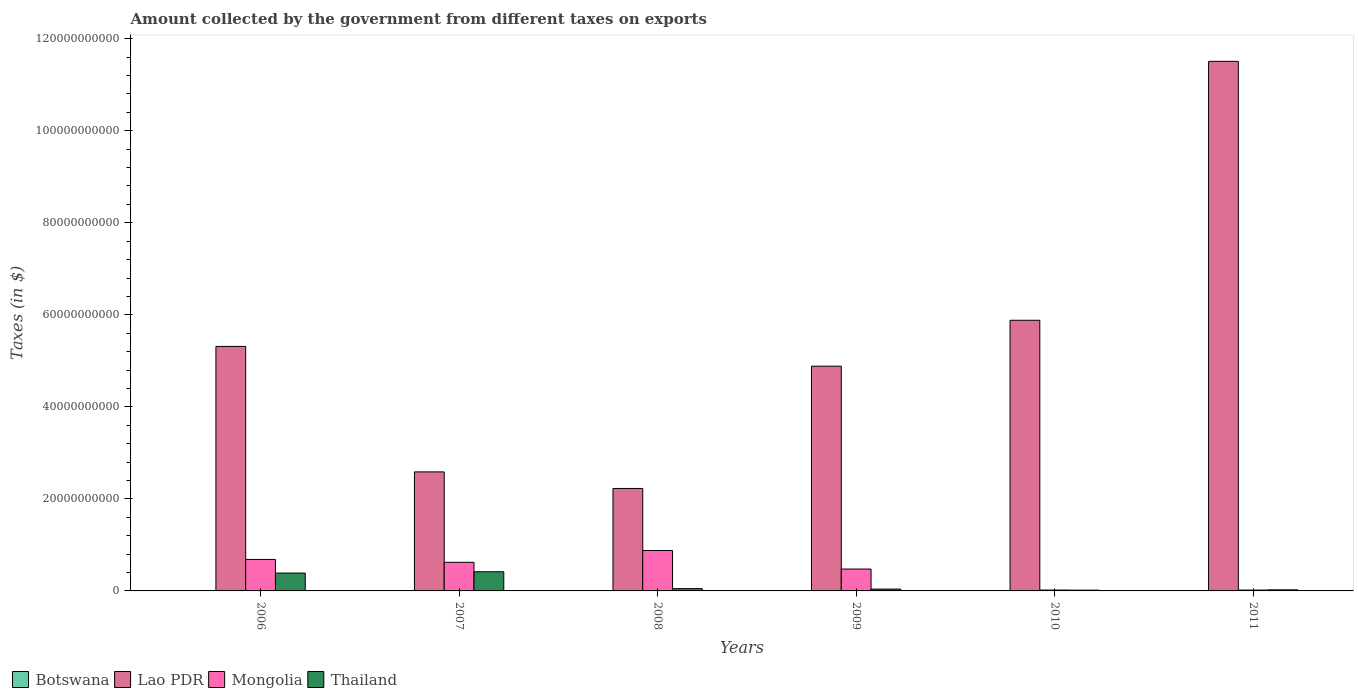How many different coloured bars are there?
Give a very brief answer. 4. Are the number of bars on each tick of the X-axis equal?
Your response must be concise. Yes. What is the label of the 4th group of bars from the left?
Provide a succinct answer. 2009. What is the amount collected by the government from taxes on exports in Lao PDR in 2011?
Offer a very short reply. 1.15e+11. Across all years, what is the maximum amount collected by the government from taxes on exports in Botswana?
Your answer should be compact. 1.69e+06. What is the total amount collected by the government from taxes on exports in Mongolia in the graph?
Offer a terse response. 2.70e+1. What is the difference between the amount collected by the government from taxes on exports in Thailand in 2008 and that in 2011?
Provide a short and direct response. 2.61e+08. What is the difference between the amount collected by the government from taxes on exports in Botswana in 2008 and the amount collected by the government from taxes on exports in Lao PDR in 2010?
Provide a succinct answer. -5.88e+1. What is the average amount collected by the government from taxes on exports in Botswana per year?
Ensure brevity in your answer.  1.04e+06. In the year 2008, what is the difference between the amount collected by the government from taxes on exports in Thailand and amount collected by the government from taxes on exports in Lao PDR?
Make the answer very short. -2.18e+1. In how many years, is the amount collected by the government from taxes on exports in Lao PDR greater than 40000000000 $?
Keep it short and to the point. 4. What is the ratio of the amount collected by the government from taxes on exports in Mongolia in 2009 to that in 2011?
Offer a terse response. 25.63. What is the difference between the highest and the second highest amount collected by the government from taxes on exports in Lao PDR?
Make the answer very short. 5.63e+1. What is the difference between the highest and the lowest amount collected by the government from taxes on exports in Lao PDR?
Give a very brief answer. 9.28e+1. In how many years, is the amount collected by the government from taxes on exports in Thailand greater than the average amount collected by the government from taxes on exports in Thailand taken over all years?
Your answer should be compact. 2. Is the sum of the amount collected by the government from taxes on exports in Lao PDR in 2007 and 2008 greater than the maximum amount collected by the government from taxes on exports in Botswana across all years?
Your response must be concise. Yes. What does the 2nd bar from the left in 2011 represents?
Your answer should be compact. Lao PDR. What does the 2nd bar from the right in 2011 represents?
Your response must be concise. Mongolia. Is it the case that in every year, the sum of the amount collected by the government from taxes on exports in Mongolia and amount collected by the government from taxes on exports in Botswana is greater than the amount collected by the government from taxes on exports in Lao PDR?
Your answer should be compact. No. Are the values on the major ticks of Y-axis written in scientific E-notation?
Your response must be concise. No. Where does the legend appear in the graph?
Your response must be concise. Bottom left. How many legend labels are there?
Provide a succinct answer. 4. What is the title of the graph?
Your response must be concise. Amount collected by the government from different taxes on exports. What is the label or title of the Y-axis?
Provide a succinct answer. Taxes (in $). What is the Taxes (in $) in Lao PDR in 2006?
Offer a very short reply. 5.31e+1. What is the Taxes (in $) in Mongolia in 2006?
Make the answer very short. 6.84e+09. What is the Taxes (in $) in Thailand in 2006?
Keep it short and to the point. 3.88e+09. What is the Taxes (in $) of Lao PDR in 2007?
Keep it short and to the point. 2.59e+1. What is the Taxes (in $) in Mongolia in 2007?
Keep it short and to the point. 6.22e+09. What is the Taxes (in $) of Thailand in 2007?
Provide a succinct answer. 4.16e+09. What is the Taxes (in $) in Botswana in 2008?
Give a very brief answer. 1.65e+06. What is the Taxes (in $) of Lao PDR in 2008?
Provide a short and direct response. 2.23e+1. What is the Taxes (in $) in Mongolia in 2008?
Offer a terse response. 8.78e+09. What is the Taxes (in $) in Botswana in 2009?
Provide a short and direct response. 7.10e+05. What is the Taxes (in $) of Lao PDR in 2009?
Keep it short and to the point. 4.88e+1. What is the Taxes (in $) in Mongolia in 2009?
Your response must be concise. 4.75e+09. What is the Taxes (in $) in Thailand in 2009?
Your answer should be very brief. 4.00e+08. What is the Taxes (in $) of Botswana in 2010?
Ensure brevity in your answer.  1.69e+06. What is the Taxes (in $) of Lao PDR in 2010?
Your response must be concise. 5.88e+1. What is the Taxes (in $) in Mongolia in 2010?
Provide a short and direct response. 1.90e+08. What is the Taxes (in $) of Thailand in 2010?
Provide a succinct answer. 1.68e+08. What is the Taxes (in $) of Botswana in 2011?
Offer a terse response. 1.36e+06. What is the Taxes (in $) of Lao PDR in 2011?
Provide a short and direct response. 1.15e+11. What is the Taxes (in $) in Mongolia in 2011?
Provide a short and direct response. 1.85e+08. What is the Taxes (in $) in Thailand in 2011?
Your answer should be very brief. 2.39e+08. Across all years, what is the maximum Taxes (in $) of Botswana?
Your answer should be compact. 1.69e+06. Across all years, what is the maximum Taxes (in $) of Lao PDR?
Give a very brief answer. 1.15e+11. Across all years, what is the maximum Taxes (in $) of Mongolia?
Provide a short and direct response. 8.78e+09. Across all years, what is the maximum Taxes (in $) of Thailand?
Offer a terse response. 4.16e+09. Across all years, what is the minimum Taxes (in $) in Botswana?
Your response must be concise. 3.60e+05. Across all years, what is the minimum Taxes (in $) in Lao PDR?
Keep it short and to the point. 2.23e+1. Across all years, what is the minimum Taxes (in $) of Mongolia?
Offer a very short reply. 1.85e+08. Across all years, what is the minimum Taxes (in $) of Thailand?
Offer a terse response. 1.68e+08. What is the total Taxes (in $) of Botswana in the graph?
Offer a very short reply. 6.21e+06. What is the total Taxes (in $) in Lao PDR in the graph?
Keep it short and to the point. 3.24e+11. What is the total Taxes (in $) in Mongolia in the graph?
Your response must be concise. 2.70e+1. What is the total Taxes (in $) of Thailand in the graph?
Your response must be concise. 9.35e+09. What is the difference between the Taxes (in $) in Botswana in 2006 and that in 2007?
Provide a short and direct response. -8.00e+04. What is the difference between the Taxes (in $) of Lao PDR in 2006 and that in 2007?
Your response must be concise. 2.73e+1. What is the difference between the Taxes (in $) of Mongolia in 2006 and that in 2007?
Offer a terse response. 6.22e+08. What is the difference between the Taxes (in $) of Thailand in 2006 and that in 2007?
Give a very brief answer. -2.84e+08. What is the difference between the Taxes (in $) in Botswana in 2006 and that in 2008?
Your answer should be very brief. -1.29e+06. What is the difference between the Taxes (in $) in Lao PDR in 2006 and that in 2008?
Make the answer very short. 3.09e+1. What is the difference between the Taxes (in $) in Mongolia in 2006 and that in 2008?
Make the answer very short. -1.94e+09. What is the difference between the Taxes (in $) of Thailand in 2006 and that in 2008?
Keep it short and to the point. 3.38e+09. What is the difference between the Taxes (in $) of Botswana in 2006 and that in 2009?
Keep it short and to the point. -3.50e+05. What is the difference between the Taxes (in $) in Lao PDR in 2006 and that in 2009?
Ensure brevity in your answer.  4.29e+09. What is the difference between the Taxes (in $) of Mongolia in 2006 and that in 2009?
Offer a terse response. 2.09e+09. What is the difference between the Taxes (in $) in Thailand in 2006 and that in 2009?
Provide a short and direct response. 3.48e+09. What is the difference between the Taxes (in $) of Botswana in 2006 and that in 2010?
Your answer should be very brief. -1.33e+06. What is the difference between the Taxes (in $) in Lao PDR in 2006 and that in 2010?
Give a very brief answer. -5.68e+09. What is the difference between the Taxes (in $) in Mongolia in 2006 and that in 2010?
Ensure brevity in your answer.  6.65e+09. What is the difference between the Taxes (in $) of Thailand in 2006 and that in 2010?
Your answer should be compact. 3.71e+09. What is the difference between the Taxes (in $) of Lao PDR in 2006 and that in 2011?
Make the answer very short. -6.19e+1. What is the difference between the Taxes (in $) of Mongolia in 2006 and that in 2011?
Keep it short and to the point. 6.65e+09. What is the difference between the Taxes (in $) of Thailand in 2006 and that in 2011?
Your answer should be compact. 3.64e+09. What is the difference between the Taxes (in $) of Botswana in 2007 and that in 2008?
Provide a succinct answer. -1.21e+06. What is the difference between the Taxes (in $) in Lao PDR in 2007 and that in 2008?
Provide a short and direct response. 3.60e+09. What is the difference between the Taxes (in $) in Mongolia in 2007 and that in 2008?
Your response must be concise. -2.56e+09. What is the difference between the Taxes (in $) of Thailand in 2007 and that in 2008?
Your answer should be compact. 3.66e+09. What is the difference between the Taxes (in $) in Lao PDR in 2007 and that in 2009?
Offer a very short reply. -2.30e+1. What is the difference between the Taxes (in $) in Mongolia in 2007 and that in 2009?
Give a very brief answer. 1.46e+09. What is the difference between the Taxes (in $) in Thailand in 2007 and that in 2009?
Offer a terse response. 3.76e+09. What is the difference between the Taxes (in $) in Botswana in 2007 and that in 2010?
Offer a very short reply. -1.25e+06. What is the difference between the Taxes (in $) of Lao PDR in 2007 and that in 2010?
Ensure brevity in your answer.  -3.30e+1. What is the difference between the Taxes (in $) in Mongolia in 2007 and that in 2010?
Your answer should be very brief. 6.03e+09. What is the difference between the Taxes (in $) in Thailand in 2007 and that in 2010?
Make the answer very short. 4.00e+09. What is the difference between the Taxes (in $) in Botswana in 2007 and that in 2011?
Keep it short and to the point. -9.20e+05. What is the difference between the Taxes (in $) of Lao PDR in 2007 and that in 2011?
Make the answer very short. -8.92e+1. What is the difference between the Taxes (in $) of Mongolia in 2007 and that in 2011?
Give a very brief answer. 6.03e+09. What is the difference between the Taxes (in $) of Thailand in 2007 and that in 2011?
Provide a succinct answer. 3.93e+09. What is the difference between the Taxes (in $) of Botswana in 2008 and that in 2009?
Provide a short and direct response. 9.40e+05. What is the difference between the Taxes (in $) of Lao PDR in 2008 and that in 2009?
Ensure brevity in your answer.  -2.66e+1. What is the difference between the Taxes (in $) of Mongolia in 2008 and that in 2009?
Your answer should be very brief. 4.03e+09. What is the difference between the Taxes (in $) in Thailand in 2008 and that in 2009?
Your answer should be compact. 9.98e+07. What is the difference between the Taxes (in $) in Lao PDR in 2008 and that in 2010?
Your answer should be very brief. -3.65e+1. What is the difference between the Taxes (in $) in Mongolia in 2008 and that in 2010?
Offer a very short reply. 8.59e+09. What is the difference between the Taxes (in $) in Thailand in 2008 and that in 2010?
Make the answer very short. 3.32e+08. What is the difference between the Taxes (in $) in Lao PDR in 2008 and that in 2011?
Your answer should be very brief. -9.28e+1. What is the difference between the Taxes (in $) in Mongolia in 2008 and that in 2011?
Keep it short and to the point. 8.60e+09. What is the difference between the Taxes (in $) in Thailand in 2008 and that in 2011?
Your answer should be compact. 2.61e+08. What is the difference between the Taxes (in $) in Botswana in 2009 and that in 2010?
Your answer should be very brief. -9.80e+05. What is the difference between the Taxes (in $) in Lao PDR in 2009 and that in 2010?
Offer a very short reply. -9.98e+09. What is the difference between the Taxes (in $) of Mongolia in 2009 and that in 2010?
Ensure brevity in your answer.  4.57e+09. What is the difference between the Taxes (in $) of Thailand in 2009 and that in 2010?
Provide a succinct answer. 2.33e+08. What is the difference between the Taxes (in $) in Botswana in 2009 and that in 2011?
Make the answer very short. -6.50e+05. What is the difference between the Taxes (in $) of Lao PDR in 2009 and that in 2011?
Make the answer very short. -6.62e+1. What is the difference between the Taxes (in $) in Mongolia in 2009 and that in 2011?
Make the answer very short. 4.57e+09. What is the difference between the Taxes (in $) in Thailand in 2009 and that in 2011?
Provide a short and direct response. 1.61e+08. What is the difference between the Taxes (in $) of Lao PDR in 2010 and that in 2011?
Give a very brief answer. -5.63e+1. What is the difference between the Taxes (in $) in Mongolia in 2010 and that in 2011?
Provide a succinct answer. 4.30e+06. What is the difference between the Taxes (in $) in Thailand in 2010 and that in 2011?
Your answer should be compact. -7.14e+07. What is the difference between the Taxes (in $) in Botswana in 2006 and the Taxes (in $) in Lao PDR in 2007?
Offer a terse response. -2.59e+1. What is the difference between the Taxes (in $) of Botswana in 2006 and the Taxes (in $) of Mongolia in 2007?
Make the answer very short. -6.22e+09. What is the difference between the Taxes (in $) of Botswana in 2006 and the Taxes (in $) of Thailand in 2007?
Keep it short and to the point. -4.16e+09. What is the difference between the Taxes (in $) of Lao PDR in 2006 and the Taxes (in $) of Mongolia in 2007?
Provide a short and direct response. 4.69e+1. What is the difference between the Taxes (in $) of Lao PDR in 2006 and the Taxes (in $) of Thailand in 2007?
Provide a short and direct response. 4.90e+1. What is the difference between the Taxes (in $) of Mongolia in 2006 and the Taxes (in $) of Thailand in 2007?
Ensure brevity in your answer.  2.68e+09. What is the difference between the Taxes (in $) of Botswana in 2006 and the Taxes (in $) of Lao PDR in 2008?
Your response must be concise. -2.23e+1. What is the difference between the Taxes (in $) in Botswana in 2006 and the Taxes (in $) in Mongolia in 2008?
Your answer should be very brief. -8.78e+09. What is the difference between the Taxes (in $) in Botswana in 2006 and the Taxes (in $) in Thailand in 2008?
Provide a short and direct response. -5.00e+08. What is the difference between the Taxes (in $) in Lao PDR in 2006 and the Taxes (in $) in Mongolia in 2008?
Make the answer very short. 4.43e+1. What is the difference between the Taxes (in $) in Lao PDR in 2006 and the Taxes (in $) in Thailand in 2008?
Provide a short and direct response. 5.26e+1. What is the difference between the Taxes (in $) in Mongolia in 2006 and the Taxes (in $) in Thailand in 2008?
Make the answer very short. 6.34e+09. What is the difference between the Taxes (in $) of Botswana in 2006 and the Taxes (in $) of Lao PDR in 2009?
Your answer should be compact. -4.88e+1. What is the difference between the Taxes (in $) in Botswana in 2006 and the Taxes (in $) in Mongolia in 2009?
Provide a short and direct response. -4.75e+09. What is the difference between the Taxes (in $) of Botswana in 2006 and the Taxes (in $) of Thailand in 2009?
Ensure brevity in your answer.  -4.00e+08. What is the difference between the Taxes (in $) in Lao PDR in 2006 and the Taxes (in $) in Mongolia in 2009?
Offer a terse response. 4.84e+1. What is the difference between the Taxes (in $) of Lao PDR in 2006 and the Taxes (in $) of Thailand in 2009?
Offer a terse response. 5.27e+1. What is the difference between the Taxes (in $) of Mongolia in 2006 and the Taxes (in $) of Thailand in 2009?
Your answer should be compact. 6.44e+09. What is the difference between the Taxes (in $) in Botswana in 2006 and the Taxes (in $) in Lao PDR in 2010?
Your answer should be compact. -5.88e+1. What is the difference between the Taxes (in $) of Botswana in 2006 and the Taxes (in $) of Mongolia in 2010?
Provide a short and direct response. -1.89e+08. What is the difference between the Taxes (in $) in Botswana in 2006 and the Taxes (in $) in Thailand in 2010?
Give a very brief answer. -1.67e+08. What is the difference between the Taxes (in $) of Lao PDR in 2006 and the Taxes (in $) of Mongolia in 2010?
Keep it short and to the point. 5.29e+1. What is the difference between the Taxes (in $) in Lao PDR in 2006 and the Taxes (in $) in Thailand in 2010?
Your response must be concise. 5.30e+1. What is the difference between the Taxes (in $) of Mongolia in 2006 and the Taxes (in $) of Thailand in 2010?
Offer a very short reply. 6.67e+09. What is the difference between the Taxes (in $) in Botswana in 2006 and the Taxes (in $) in Lao PDR in 2011?
Keep it short and to the point. -1.15e+11. What is the difference between the Taxes (in $) of Botswana in 2006 and the Taxes (in $) of Mongolia in 2011?
Your answer should be very brief. -1.85e+08. What is the difference between the Taxes (in $) in Botswana in 2006 and the Taxes (in $) in Thailand in 2011?
Give a very brief answer. -2.39e+08. What is the difference between the Taxes (in $) in Lao PDR in 2006 and the Taxes (in $) in Mongolia in 2011?
Provide a short and direct response. 5.29e+1. What is the difference between the Taxes (in $) of Lao PDR in 2006 and the Taxes (in $) of Thailand in 2011?
Make the answer very short. 5.29e+1. What is the difference between the Taxes (in $) of Mongolia in 2006 and the Taxes (in $) of Thailand in 2011?
Ensure brevity in your answer.  6.60e+09. What is the difference between the Taxes (in $) of Botswana in 2007 and the Taxes (in $) of Lao PDR in 2008?
Provide a short and direct response. -2.23e+1. What is the difference between the Taxes (in $) of Botswana in 2007 and the Taxes (in $) of Mongolia in 2008?
Provide a succinct answer. -8.78e+09. What is the difference between the Taxes (in $) in Botswana in 2007 and the Taxes (in $) in Thailand in 2008?
Make the answer very short. -5.00e+08. What is the difference between the Taxes (in $) in Lao PDR in 2007 and the Taxes (in $) in Mongolia in 2008?
Offer a terse response. 1.71e+1. What is the difference between the Taxes (in $) in Lao PDR in 2007 and the Taxes (in $) in Thailand in 2008?
Your answer should be very brief. 2.54e+1. What is the difference between the Taxes (in $) in Mongolia in 2007 and the Taxes (in $) in Thailand in 2008?
Your answer should be very brief. 5.72e+09. What is the difference between the Taxes (in $) in Botswana in 2007 and the Taxes (in $) in Lao PDR in 2009?
Your response must be concise. -4.88e+1. What is the difference between the Taxes (in $) of Botswana in 2007 and the Taxes (in $) of Mongolia in 2009?
Give a very brief answer. -4.75e+09. What is the difference between the Taxes (in $) in Botswana in 2007 and the Taxes (in $) in Thailand in 2009?
Provide a short and direct response. -4.00e+08. What is the difference between the Taxes (in $) in Lao PDR in 2007 and the Taxes (in $) in Mongolia in 2009?
Offer a very short reply. 2.11e+1. What is the difference between the Taxes (in $) of Lao PDR in 2007 and the Taxes (in $) of Thailand in 2009?
Keep it short and to the point. 2.55e+1. What is the difference between the Taxes (in $) in Mongolia in 2007 and the Taxes (in $) in Thailand in 2009?
Your answer should be very brief. 5.82e+09. What is the difference between the Taxes (in $) of Botswana in 2007 and the Taxes (in $) of Lao PDR in 2010?
Your answer should be compact. -5.88e+1. What is the difference between the Taxes (in $) in Botswana in 2007 and the Taxes (in $) in Mongolia in 2010?
Offer a terse response. -1.89e+08. What is the difference between the Taxes (in $) in Botswana in 2007 and the Taxes (in $) in Thailand in 2010?
Make the answer very short. -1.67e+08. What is the difference between the Taxes (in $) of Lao PDR in 2007 and the Taxes (in $) of Mongolia in 2010?
Make the answer very short. 2.57e+1. What is the difference between the Taxes (in $) of Lao PDR in 2007 and the Taxes (in $) of Thailand in 2010?
Make the answer very short. 2.57e+1. What is the difference between the Taxes (in $) of Mongolia in 2007 and the Taxes (in $) of Thailand in 2010?
Offer a very short reply. 6.05e+09. What is the difference between the Taxes (in $) of Botswana in 2007 and the Taxes (in $) of Lao PDR in 2011?
Offer a terse response. -1.15e+11. What is the difference between the Taxes (in $) of Botswana in 2007 and the Taxes (in $) of Mongolia in 2011?
Your answer should be compact. -1.85e+08. What is the difference between the Taxes (in $) of Botswana in 2007 and the Taxes (in $) of Thailand in 2011?
Provide a short and direct response. -2.38e+08. What is the difference between the Taxes (in $) in Lao PDR in 2007 and the Taxes (in $) in Mongolia in 2011?
Offer a very short reply. 2.57e+1. What is the difference between the Taxes (in $) of Lao PDR in 2007 and the Taxes (in $) of Thailand in 2011?
Ensure brevity in your answer.  2.56e+1. What is the difference between the Taxes (in $) in Mongolia in 2007 and the Taxes (in $) in Thailand in 2011?
Offer a terse response. 5.98e+09. What is the difference between the Taxes (in $) in Botswana in 2008 and the Taxes (in $) in Lao PDR in 2009?
Offer a very short reply. -4.88e+1. What is the difference between the Taxes (in $) in Botswana in 2008 and the Taxes (in $) in Mongolia in 2009?
Give a very brief answer. -4.75e+09. What is the difference between the Taxes (in $) of Botswana in 2008 and the Taxes (in $) of Thailand in 2009?
Your answer should be very brief. -3.99e+08. What is the difference between the Taxes (in $) in Lao PDR in 2008 and the Taxes (in $) in Mongolia in 2009?
Provide a short and direct response. 1.75e+1. What is the difference between the Taxes (in $) in Lao PDR in 2008 and the Taxes (in $) in Thailand in 2009?
Offer a terse response. 2.19e+1. What is the difference between the Taxes (in $) of Mongolia in 2008 and the Taxes (in $) of Thailand in 2009?
Keep it short and to the point. 8.38e+09. What is the difference between the Taxes (in $) of Botswana in 2008 and the Taxes (in $) of Lao PDR in 2010?
Provide a succinct answer. -5.88e+1. What is the difference between the Taxes (in $) in Botswana in 2008 and the Taxes (in $) in Mongolia in 2010?
Your answer should be compact. -1.88e+08. What is the difference between the Taxes (in $) in Botswana in 2008 and the Taxes (in $) in Thailand in 2010?
Provide a short and direct response. -1.66e+08. What is the difference between the Taxes (in $) of Lao PDR in 2008 and the Taxes (in $) of Mongolia in 2010?
Your answer should be compact. 2.21e+1. What is the difference between the Taxes (in $) of Lao PDR in 2008 and the Taxes (in $) of Thailand in 2010?
Offer a very short reply. 2.21e+1. What is the difference between the Taxes (in $) of Mongolia in 2008 and the Taxes (in $) of Thailand in 2010?
Make the answer very short. 8.61e+09. What is the difference between the Taxes (in $) in Botswana in 2008 and the Taxes (in $) in Lao PDR in 2011?
Make the answer very short. -1.15e+11. What is the difference between the Taxes (in $) in Botswana in 2008 and the Taxes (in $) in Mongolia in 2011?
Keep it short and to the point. -1.84e+08. What is the difference between the Taxes (in $) in Botswana in 2008 and the Taxes (in $) in Thailand in 2011?
Give a very brief answer. -2.37e+08. What is the difference between the Taxes (in $) of Lao PDR in 2008 and the Taxes (in $) of Mongolia in 2011?
Your answer should be compact. 2.21e+1. What is the difference between the Taxes (in $) of Lao PDR in 2008 and the Taxes (in $) of Thailand in 2011?
Offer a very short reply. 2.20e+1. What is the difference between the Taxes (in $) in Mongolia in 2008 and the Taxes (in $) in Thailand in 2011?
Offer a very short reply. 8.54e+09. What is the difference between the Taxes (in $) in Botswana in 2009 and the Taxes (in $) in Lao PDR in 2010?
Offer a terse response. -5.88e+1. What is the difference between the Taxes (in $) in Botswana in 2009 and the Taxes (in $) in Mongolia in 2010?
Keep it short and to the point. -1.89e+08. What is the difference between the Taxes (in $) in Botswana in 2009 and the Taxes (in $) in Thailand in 2010?
Ensure brevity in your answer.  -1.67e+08. What is the difference between the Taxes (in $) of Lao PDR in 2009 and the Taxes (in $) of Mongolia in 2010?
Ensure brevity in your answer.  4.86e+1. What is the difference between the Taxes (in $) of Lao PDR in 2009 and the Taxes (in $) of Thailand in 2010?
Provide a short and direct response. 4.87e+1. What is the difference between the Taxes (in $) in Mongolia in 2009 and the Taxes (in $) in Thailand in 2010?
Keep it short and to the point. 4.59e+09. What is the difference between the Taxes (in $) in Botswana in 2009 and the Taxes (in $) in Lao PDR in 2011?
Make the answer very short. -1.15e+11. What is the difference between the Taxes (in $) in Botswana in 2009 and the Taxes (in $) in Mongolia in 2011?
Keep it short and to the point. -1.85e+08. What is the difference between the Taxes (in $) in Botswana in 2009 and the Taxes (in $) in Thailand in 2011?
Ensure brevity in your answer.  -2.38e+08. What is the difference between the Taxes (in $) of Lao PDR in 2009 and the Taxes (in $) of Mongolia in 2011?
Keep it short and to the point. 4.87e+1. What is the difference between the Taxes (in $) of Lao PDR in 2009 and the Taxes (in $) of Thailand in 2011?
Provide a succinct answer. 4.86e+1. What is the difference between the Taxes (in $) in Mongolia in 2009 and the Taxes (in $) in Thailand in 2011?
Your answer should be very brief. 4.52e+09. What is the difference between the Taxes (in $) in Botswana in 2010 and the Taxes (in $) in Lao PDR in 2011?
Your answer should be compact. -1.15e+11. What is the difference between the Taxes (in $) in Botswana in 2010 and the Taxes (in $) in Mongolia in 2011?
Your response must be concise. -1.84e+08. What is the difference between the Taxes (in $) of Botswana in 2010 and the Taxes (in $) of Thailand in 2011?
Your answer should be compact. -2.37e+08. What is the difference between the Taxes (in $) of Lao PDR in 2010 and the Taxes (in $) of Mongolia in 2011?
Provide a short and direct response. 5.86e+1. What is the difference between the Taxes (in $) in Lao PDR in 2010 and the Taxes (in $) in Thailand in 2011?
Keep it short and to the point. 5.86e+1. What is the difference between the Taxes (in $) in Mongolia in 2010 and the Taxes (in $) in Thailand in 2011?
Your response must be concise. -4.91e+07. What is the average Taxes (in $) of Botswana per year?
Provide a succinct answer. 1.04e+06. What is the average Taxes (in $) of Lao PDR per year?
Offer a terse response. 5.40e+1. What is the average Taxes (in $) of Mongolia per year?
Ensure brevity in your answer.  4.50e+09. What is the average Taxes (in $) in Thailand per year?
Provide a short and direct response. 1.56e+09. In the year 2006, what is the difference between the Taxes (in $) of Botswana and Taxes (in $) of Lao PDR?
Provide a succinct answer. -5.31e+1. In the year 2006, what is the difference between the Taxes (in $) of Botswana and Taxes (in $) of Mongolia?
Provide a short and direct response. -6.84e+09. In the year 2006, what is the difference between the Taxes (in $) of Botswana and Taxes (in $) of Thailand?
Your response must be concise. -3.88e+09. In the year 2006, what is the difference between the Taxes (in $) in Lao PDR and Taxes (in $) in Mongolia?
Keep it short and to the point. 4.63e+1. In the year 2006, what is the difference between the Taxes (in $) in Lao PDR and Taxes (in $) in Thailand?
Provide a succinct answer. 4.93e+1. In the year 2006, what is the difference between the Taxes (in $) of Mongolia and Taxes (in $) of Thailand?
Your answer should be very brief. 2.96e+09. In the year 2007, what is the difference between the Taxes (in $) of Botswana and Taxes (in $) of Lao PDR?
Provide a short and direct response. -2.59e+1. In the year 2007, what is the difference between the Taxes (in $) of Botswana and Taxes (in $) of Mongolia?
Offer a terse response. -6.22e+09. In the year 2007, what is the difference between the Taxes (in $) in Botswana and Taxes (in $) in Thailand?
Provide a succinct answer. -4.16e+09. In the year 2007, what is the difference between the Taxes (in $) of Lao PDR and Taxes (in $) of Mongolia?
Provide a succinct answer. 1.96e+1. In the year 2007, what is the difference between the Taxes (in $) of Lao PDR and Taxes (in $) of Thailand?
Make the answer very short. 2.17e+1. In the year 2007, what is the difference between the Taxes (in $) of Mongolia and Taxes (in $) of Thailand?
Ensure brevity in your answer.  2.05e+09. In the year 2008, what is the difference between the Taxes (in $) in Botswana and Taxes (in $) in Lao PDR?
Your answer should be very brief. -2.23e+1. In the year 2008, what is the difference between the Taxes (in $) in Botswana and Taxes (in $) in Mongolia?
Offer a terse response. -8.78e+09. In the year 2008, what is the difference between the Taxes (in $) in Botswana and Taxes (in $) in Thailand?
Offer a very short reply. -4.98e+08. In the year 2008, what is the difference between the Taxes (in $) of Lao PDR and Taxes (in $) of Mongolia?
Ensure brevity in your answer.  1.35e+1. In the year 2008, what is the difference between the Taxes (in $) of Lao PDR and Taxes (in $) of Thailand?
Make the answer very short. 2.18e+1. In the year 2008, what is the difference between the Taxes (in $) in Mongolia and Taxes (in $) in Thailand?
Your answer should be compact. 8.28e+09. In the year 2009, what is the difference between the Taxes (in $) in Botswana and Taxes (in $) in Lao PDR?
Provide a short and direct response. -4.88e+1. In the year 2009, what is the difference between the Taxes (in $) in Botswana and Taxes (in $) in Mongolia?
Provide a short and direct response. -4.75e+09. In the year 2009, what is the difference between the Taxes (in $) in Botswana and Taxes (in $) in Thailand?
Provide a succinct answer. -3.99e+08. In the year 2009, what is the difference between the Taxes (in $) in Lao PDR and Taxes (in $) in Mongolia?
Offer a very short reply. 4.41e+1. In the year 2009, what is the difference between the Taxes (in $) of Lao PDR and Taxes (in $) of Thailand?
Make the answer very short. 4.84e+1. In the year 2009, what is the difference between the Taxes (in $) in Mongolia and Taxes (in $) in Thailand?
Your response must be concise. 4.35e+09. In the year 2010, what is the difference between the Taxes (in $) of Botswana and Taxes (in $) of Lao PDR?
Your answer should be very brief. -5.88e+1. In the year 2010, what is the difference between the Taxes (in $) of Botswana and Taxes (in $) of Mongolia?
Provide a short and direct response. -1.88e+08. In the year 2010, what is the difference between the Taxes (in $) of Botswana and Taxes (in $) of Thailand?
Give a very brief answer. -1.66e+08. In the year 2010, what is the difference between the Taxes (in $) in Lao PDR and Taxes (in $) in Mongolia?
Provide a short and direct response. 5.86e+1. In the year 2010, what is the difference between the Taxes (in $) of Lao PDR and Taxes (in $) of Thailand?
Offer a very short reply. 5.86e+1. In the year 2010, what is the difference between the Taxes (in $) in Mongolia and Taxes (in $) in Thailand?
Provide a succinct answer. 2.23e+07. In the year 2011, what is the difference between the Taxes (in $) in Botswana and Taxes (in $) in Lao PDR?
Give a very brief answer. -1.15e+11. In the year 2011, what is the difference between the Taxes (in $) of Botswana and Taxes (in $) of Mongolia?
Make the answer very short. -1.84e+08. In the year 2011, what is the difference between the Taxes (in $) in Botswana and Taxes (in $) in Thailand?
Offer a very short reply. -2.38e+08. In the year 2011, what is the difference between the Taxes (in $) of Lao PDR and Taxes (in $) of Mongolia?
Keep it short and to the point. 1.15e+11. In the year 2011, what is the difference between the Taxes (in $) of Lao PDR and Taxes (in $) of Thailand?
Make the answer very short. 1.15e+11. In the year 2011, what is the difference between the Taxes (in $) of Mongolia and Taxes (in $) of Thailand?
Offer a very short reply. -5.34e+07. What is the ratio of the Taxes (in $) in Botswana in 2006 to that in 2007?
Ensure brevity in your answer.  0.82. What is the ratio of the Taxes (in $) of Lao PDR in 2006 to that in 2007?
Provide a succinct answer. 2.05. What is the ratio of the Taxes (in $) of Thailand in 2006 to that in 2007?
Your answer should be very brief. 0.93. What is the ratio of the Taxes (in $) in Botswana in 2006 to that in 2008?
Your answer should be very brief. 0.22. What is the ratio of the Taxes (in $) in Lao PDR in 2006 to that in 2008?
Offer a terse response. 2.39. What is the ratio of the Taxes (in $) of Mongolia in 2006 to that in 2008?
Make the answer very short. 0.78. What is the ratio of the Taxes (in $) of Thailand in 2006 to that in 2008?
Keep it short and to the point. 7.76. What is the ratio of the Taxes (in $) of Botswana in 2006 to that in 2009?
Offer a terse response. 0.51. What is the ratio of the Taxes (in $) in Lao PDR in 2006 to that in 2009?
Make the answer very short. 1.09. What is the ratio of the Taxes (in $) of Mongolia in 2006 to that in 2009?
Keep it short and to the point. 1.44. What is the ratio of the Taxes (in $) in Thailand in 2006 to that in 2009?
Provide a succinct answer. 9.7. What is the ratio of the Taxes (in $) of Botswana in 2006 to that in 2010?
Provide a short and direct response. 0.21. What is the ratio of the Taxes (in $) in Lao PDR in 2006 to that in 2010?
Your answer should be compact. 0.9. What is the ratio of the Taxes (in $) of Mongolia in 2006 to that in 2010?
Make the answer very short. 36.04. What is the ratio of the Taxes (in $) in Thailand in 2006 to that in 2010?
Offer a terse response. 23.16. What is the ratio of the Taxes (in $) in Botswana in 2006 to that in 2011?
Your answer should be compact. 0.26. What is the ratio of the Taxes (in $) in Lao PDR in 2006 to that in 2011?
Provide a short and direct response. 0.46. What is the ratio of the Taxes (in $) in Mongolia in 2006 to that in 2011?
Provide a succinct answer. 36.88. What is the ratio of the Taxes (in $) in Thailand in 2006 to that in 2011?
Your response must be concise. 16.24. What is the ratio of the Taxes (in $) in Botswana in 2007 to that in 2008?
Give a very brief answer. 0.27. What is the ratio of the Taxes (in $) in Lao PDR in 2007 to that in 2008?
Give a very brief answer. 1.16. What is the ratio of the Taxes (in $) in Mongolia in 2007 to that in 2008?
Provide a short and direct response. 0.71. What is the ratio of the Taxes (in $) in Thailand in 2007 to that in 2008?
Make the answer very short. 8.33. What is the ratio of the Taxes (in $) of Botswana in 2007 to that in 2009?
Provide a succinct answer. 0.62. What is the ratio of the Taxes (in $) of Lao PDR in 2007 to that in 2009?
Your answer should be very brief. 0.53. What is the ratio of the Taxes (in $) of Mongolia in 2007 to that in 2009?
Your response must be concise. 1.31. What is the ratio of the Taxes (in $) in Thailand in 2007 to that in 2009?
Give a very brief answer. 10.41. What is the ratio of the Taxes (in $) of Botswana in 2007 to that in 2010?
Make the answer very short. 0.26. What is the ratio of the Taxes (in $) of Lao PDR in 2007 to that in 2010?
Make the answer very short. 0.44. What is the ratio of the Taxes (in $) in Mongolia in 2007 to that in 2010?
Make the answer very short. 32.76. What is the ratio of the Taxes (in $) in Thailand in 2007 to that in 2010?
Give a very brief answer. 24.86. What is the ratio of the Taxes (in $) of Botswana in 2007 to that in 2011?
Make the answer very short. 0.32. What is the ratio of the Taxes (in $) of Lao PDR in 2007 to that in 2011?
Keep it short and to the point. 0.22. What is the ratio of the Taxes (in $) of Mongolia in 2007 to that in 2011?
Make the answer very short. 33.52. What is the ratio of the Taxes (in $) of Thailand in 2007 to that in 2011?
Your answer should be compact. 17.43. What is the ratio of the Taxes (in $) of Botswana in 2008 to that in 2009?
Provide a short and direct response. 2.32. What is the ratio of the Taxes (in $) of Lao PDR in 2008 to that in 2009?
Offer a very short reply. 0.46. What is the ratio of the Taxes (in $) in Mongolia in 2008 to that in 2009?
Your response must be concise. 1.85. What is the ratio of the Taxes (in $) in Thailand in 2008 to that in 2009?
Your response must be concise. 1.25. What is the ratio of the Taxes (in $) in Botswana in 2008 to that in 2010?
Offer a terse response. 0.98. What is the ratio of the Taxes (in $) of Lao PDR in 2008 to that in 2010?
Give a very brief answer. 0.38. What is the ratio of the Taxes (in $) in Mongolia in 2008 to that in 2010?
Ensure brevity in your answer.  46.27. What is the ratio of the Taxes (in $) of Thailand in 2008 to that in 2010?
Offer a terse response. 2.98. What is the ratio of the Taxes (in $) of Botswana in 2008 to that in 2011?
Offer a terse response. 1.21. What is the ratio of the Taxes (in $) in Lao PDR in 2008 to that in 2011?
Offer a very short reply. 0.19. What is the ratio of the Taxes (in $) in Mongolia in 2008 to that in 2011?
Provide a short and direct response. 47.35. What is the ratio of the Taxes (in $) in Thailand in 2008 to that in 2011?
Provide a succinct answer. 2.09. What is the ratio of the Taxes (in $) of Botswana in 2009 to that in 2010?
Your response must be concise. 0.42. What is the ratio of the Taxes (in $) in Lao PDR in 2009 to that in 2010?
Your response must be concise. 0.83. What is the ratio of the Taxes (in $) of Mongolia in 2009 to that in 2010?
Your response must be concise. 25.05. What is the ratio of the Taxes (in $) in Thailand in 2009 to that in 2010?
Ensure brevity in your answer.  2.39. What is the ratio of the Taxes (in $) in Botswana in 2009 to that in 2011?
Keep it short and to the point. 0.52. What is the ratio of the Taxes (in $) of Lao PDR in 2009 to that in 2011?
Your response must be concise. 0.42. What is the ratio of the Taxes (in $) in Mongolia in 2009 to that in 2011?
Offer a terse response. 25.63. What is the ratio of the Taxes (in $) of Thailand in 2009 to that in 2011?
Offer a terse response. 1.68. What is the ratio of the Taxes (in $) in Botswana in 2010 to that in 2011?
Provide a short and direct response. 1.24. What is the ratio of the Taxes (in $) of Lao PDR in 2010 to that in 2011?
Provide a succinct answer. 0.51. What is the ratio of the Taxes (in $) in Mongolia in 2010 to that in 2011?
Provide a succinct answer. 1.02. What is the ratio of the Taxes (in $) of Thailand in 2010 to that in 2011?
Provide a short and direct response. 0.7. What is the difference between the highest and the second highest Taxes (in $) in Botswana?
Give a very brief answer. 4.00e+04. What is the difference between the highest and the second highest Taxes (in $) of Lao PDR?
Provide a short and direct response. 5.63e+1. What is the difference between the highest and the second highest Taxes (in $) in Mongolia?
Your response must be concise. 1.94e+09. What is the difference between the highest and the second highest Taxes (in $) of Thailand?
Provide a short and direct response. 2.84e+08. What is the difference between the highest and the lowest Taxes (in $) in Botswana?
Your answer should be very brief. 1.33e+06. What is the difference between the highest and the lowest Taxes (in $) of Lao PDR?
Make the answer very short. 9.28e+1. What is the difference between the highest and the lowest Taxes (in $) in Mongolia?
Give a very brief answer. 8.60e+09. What is the difference between the highest and the lowest Taxes (in $) in Thailand?
Your answer should be compact. 4.00e+09. 